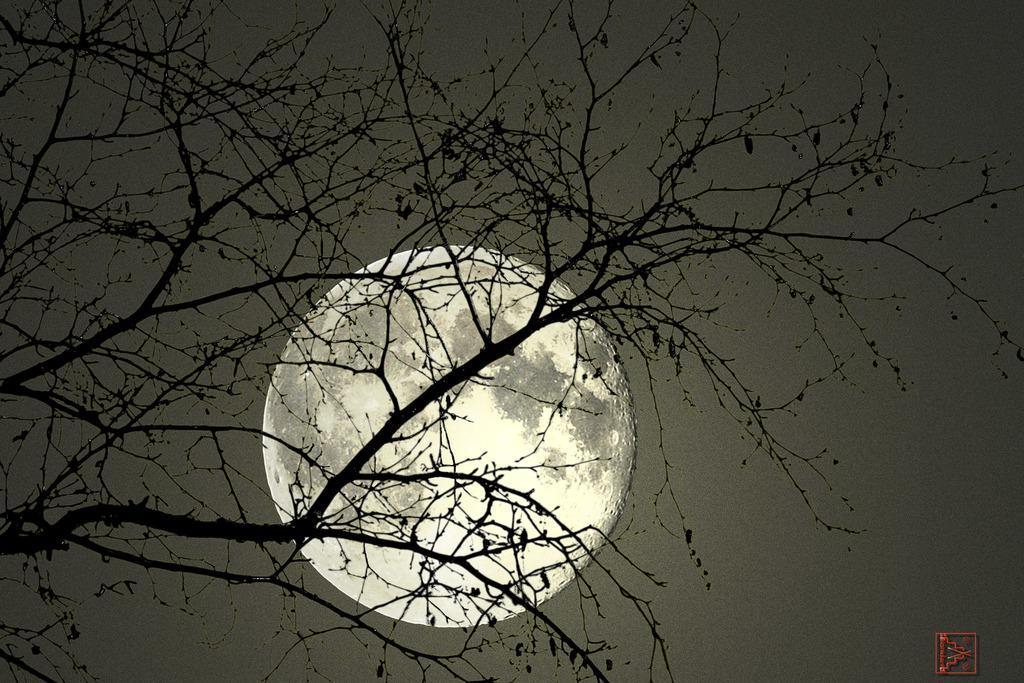In one or two sentences, can you explain what this image depicts? In the image I can see a tree. In the background I can see the moon and the sky. 